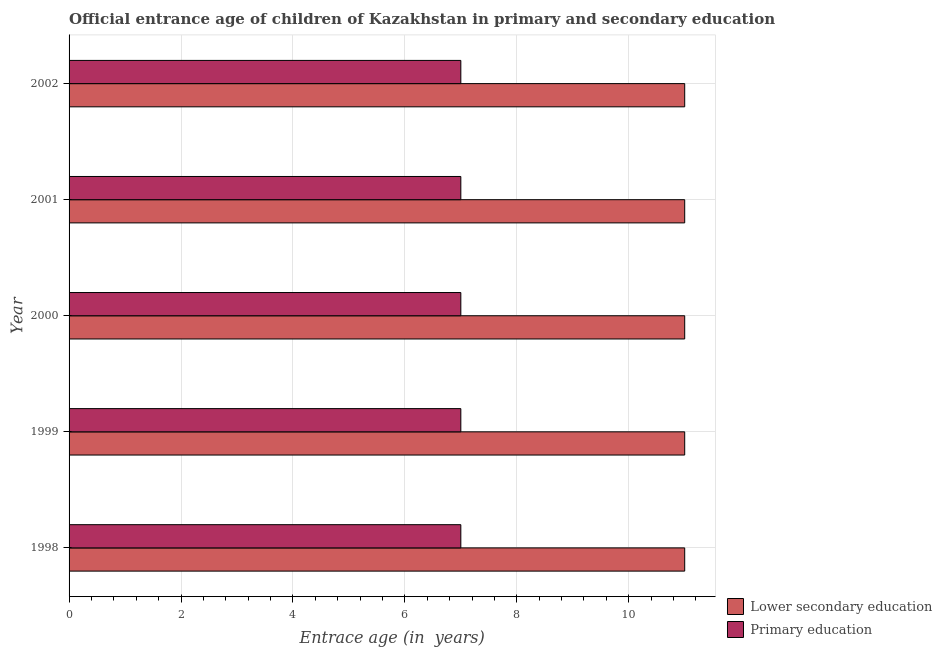How many different coloured bars are there?
Your answer should be compact. 2. How many bars are there on the 3rd tick from the top?
Keep it short and to the point. 2. What is the label of the 2nd group of bars from the top?
Your answer should be very brief. 2001. What is the entrance age of children in lower secondary education in 2000?
Ensure brevity in your answer.  11. Across all years, what is the maximum entrance age of children in lower secondary education?
Provide a short and direct response. 11. Across all years, what is the minimum entrance age of chiildren in primary education?
Offer a very short reply. 7. In which year was the entrance age of children in lower secondary education minimum?
Offer a very short reply. 1998. What is the total entrance age of children in lower secondary education in the graph?
Offer a very short reply. 55. What is the difference between the entrance age of chiildren in primary education in 1998 and that in 2002?
Provide a short and direct response. 0. What is the difference between the entrance age of children in lower secondary education in 2000 and the entrance age of chiildren in primary education in 2001?
Keep it short and to the point. 4. What is the average entrance age of children in lower secondary education per year?
Provide a succinct answer. 11. In the year 1999, what is the difference between the entrance age of chiildren in primary education and entrance age of children in lower secondary education?
Ensure brevity in your answer.  -4. In how many years, is the entrance age of chiildren in primary education greater than 9.2 years?
Your answer should be very brief. 0. Is the difference between the entrance age of chiildren in primary education in 1998 and 2002 greater than the difference between the entrance age of children in lower secondary education in 1998 and 2002?
Give a very brief answer. No. What is the difference between the highest and the lowest entrance age of children in lower secondary education?
Provide a succinct answer. 0. In how many years, is the entrance age of children in lower secondary education greater than the average entrance age of children in lower secondary education taken over all years?
Provide a short and direct response. 0. Is the sum of the entrance age of children in lower secondary education in 2001 and 2002 greater than the maximum entrance age of chiildren in primary education across all years?
Your answer should be compact. Yes. What does the 2nd bar from the top in 1998 represents?
Make the answer very short. Lower secondary education. How many bars are there?
Your answer should be very brief. 10. Where does the legend appear in the graph?
Give a very brief answer. Bottom right. How many legend labels are there?
Your answer should be very brief. 2. What is the title of the graph?
Keep it short and to the point. Official entrance age of children of Kazakhstan in primary and secondary education. What is the label or title of the X-axis?
Give a very brief answer. Entrace age (in  years). What is the Entrace age (in  years) of Primary education in 1998?
Provide a short and direct response. 7. What is the Entrace age (in  years) of Primary education in 1999?
Ensure brevity in your answer.  7. What is the Entrace age (in  years) of Lower secondary education in 2000?
Provide a succinct answer. 11. What is the Entrace age (in  years) in Primary education in 2000?
Your answer should be very brief. 7. Across all years, what is the maximum Entrace age (in  years) of Lower secondary education?
Keep it short and to the point. 11. What is the difference between the Entrace age (in  years) of Primary education in 1998 and that in 1999?
Your answer should be very brief. 0. What is the difference between the Entrace age (in  years) of Lower secondary education in 1998 and that in 2000?
Keep it short and to the point. 0. What is the difference between the Entrace age (in  years) of Lower secondary education in 1999 and that in 2001?
Your response must be concise. 0. What is the difference between the Entrace age (in  years) in Primary education in 1999 and that in 2002?
Keep it short and to the point. 0. What is the difference between the Entrace age (in  years) of Primary education in 2000 and that in 2001?
Offer a terse response. 0. What is the difference between the Entrace age (in  years) in Lower secondary education in 2001 and that in 2002?
Give a very brief answer. 0. What is the difference between the Entrace age (in  years) of Primary education in 2001 and that in 2002?
Make the answer very short. 0. What is the difference between the Entrace age (in  years) in Lower secondary education in 1998 and the Entrace age (in  years) in Primary education in 1999?
Ensure brevity in your answer.  4. What is the difference between the Entrace age (in  years) in Lower secondary education in 1998 and the Entrace age (in  years) in Primary education in 2001?
Make the answer very short. 4. What is the difference between the Entrace age (in  years) of Lower secondary education in 1998 and the Entrace age (in  years) of Primary education in 2002?
Ensure brevity in your answer.  4. What is the difference between the Entrace age (in  years) of Lower secondary education in 1999 and the Entrace age (in  years) of Primary education in 2000?
Offer a very short reply. 4. What is the difference between the Entrace age (in  years) of Lower secondary education in 1999 and the Entrace age (in  years) of Primary education in 2002?
Your response must be concise. 4. What is the difference between the Entrace age (in  years) in Lower secondary education in 2000 and the Entrace age (in  years) in Primary education in 2001?
Provide a succinct answer. 4. In the year 1998, what is the difference between the Entrace age (in  years) in Lower secondary education and Entrace age (in  years) in Primary education?
Make the answer very short. 4. What is the ratio of the Entrace age (in  years) of Primary education in 1998 to that in 1999?
Keep it short and to the point. 1. What is the ratio of the Entrace age (in  years) of Lower secondary education in 1998 to that in 2000?
Your response must be concise. 1. What is the ratio of the Entrace age (in  years) of Lower secondary education in 1998 to that in 2001?
Your response must be concise. 1. What is the ratio of the Entrace age (in  years) of Primary education in 1998 to that in 2001?
Your response must be concise. 1. What is the ratio of the Entrace age (in  years) in Primary education in 1998 to that in 2002?
Your answer should be very brief. 1. What is the ratio of the Entrace age (in  years) of Primary education in 1999 to that in 2002?
Offer a terse response. 1. What is the ratio of the Entrace age (in  years) in Lower secondary education in 2000 to that in 2001?
Provide a succinct answer. 1. What is the ratio of the Entrace age (in  years) of Primary education in 2000 to that in 2001?
Your answer should be compact. 1. What is the ratio of the Entrace age (in  years) of Lower secondary education in 2000 to that in 2002?
Offer a very short reply. 1. What is the ratio of the Entrace age (in  years) in Primary education in 2000 to that in 2002?
Keep it short and to the point. 1. What is the ratio of the Entrace age (in  years) in Lower secondary education in 2001 to that in 2002?
Your response must be concise. 1. What is the difference between the highest and the second highest Entrace age (in  years) in Lower secondary education?
Make the answer very short. 0. What is the difference between the highest and the lowest Entrace age (in  years) in Primary education?
Offer a very short reply. 0. 